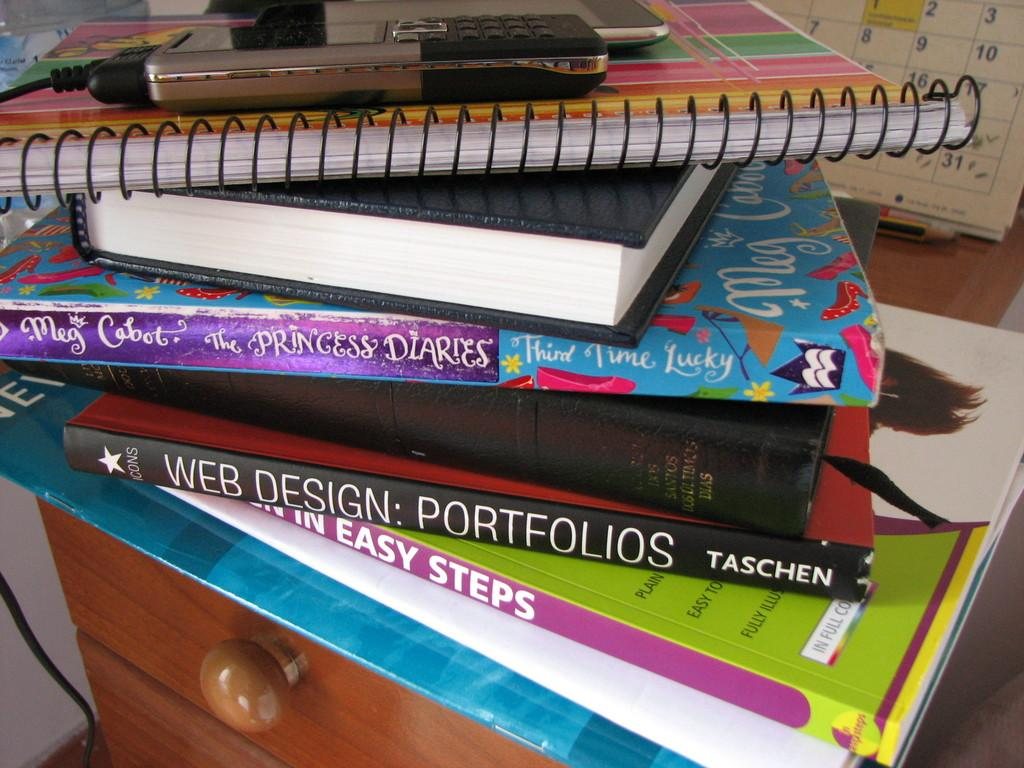What is the main subject of the image? The main subject of the image is lots of books. What object is placed on top of the books? There is a mobile phone on top of the books. What type of mythical creatures can be seen in the image? There are fairies depicted in the image. Are there any other books visible in the image? Yes, there are other books below the fairies. What stationery item is visible behind the books? There is a pencil visible behind the books. What item might be used for tracking dates and appointments in the image? There is a calendar in the image. What type of cork can be seen in the image? There is no cork present in the image. How are the fairies transporting the books in the image? The fairies are not shown transporting the books in the image; they are depicted as stationary. 